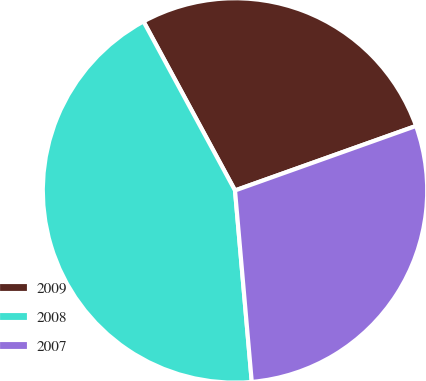Convert chart. <chart><loc_0><loc_0><loc_500><loc_500><pie_chart><fcel>2009<fcel>2008<fcel>2007<nl><fcel>27.45%<fcel>43.49%<fcel>29.06%<nl></chart> 